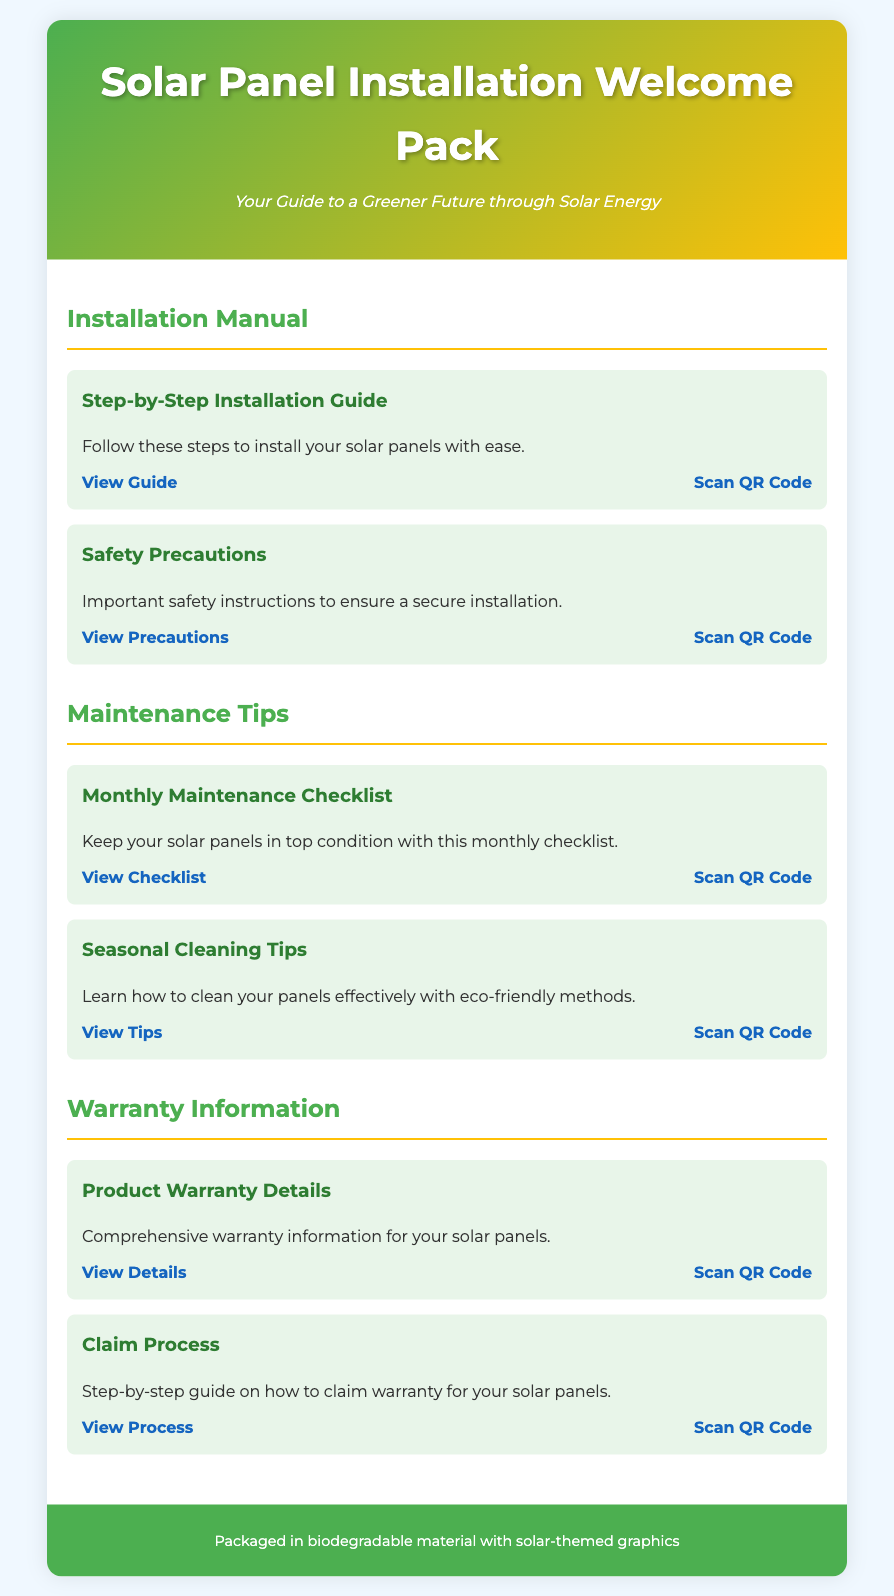What is the title of the document? The title is presented in the header section of the document.
Answer: Solar Panel Installation Welcome Pack How many sections are there in the content? The document contains three main sections, each covering different aspects of solar panel installation and maintenance.
Answer: Three What is the first item listed under the Installation Manual section? The first item provides a step-by-step guide for the installation process.
Answer: Step-by-Step Installation Guide Which color is used for the header background? The header uses a gradient color scheme, comprising two main colors.
Answer: Green and yellow What type of material is the welcome pack packaged in? This information is mentioned in the footer section of the document.
Answer: Biodegradable material What should you scan for safety precautions? The document provides a QR code link specifically for safety precautions.
Answer: Scan QR Code What is indicated as essential for the regular upkeep of solar panels? The maintenance section includes a specific checklist for monitoring solar panel health.
Answer: Monthly Maintenance Checklist How can you view the renewable energy warranty details? The document provides a direct link under the warranty information section.
Answer: View Details What is the subtitle of the welcome pack? The subtitle gives insight into the purpose of the document.
Answer: Your Guide to a Greener Future through Solar Energy 